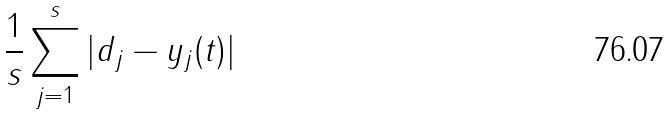Convert formula to latex. <formula><loc_0><loc_0><loc_500><loc_500>\frac { 1 } { s } \sum _ { j = 1 } ^ { s } | d _ { j } - y _ { j } ( t ) |</formula> 